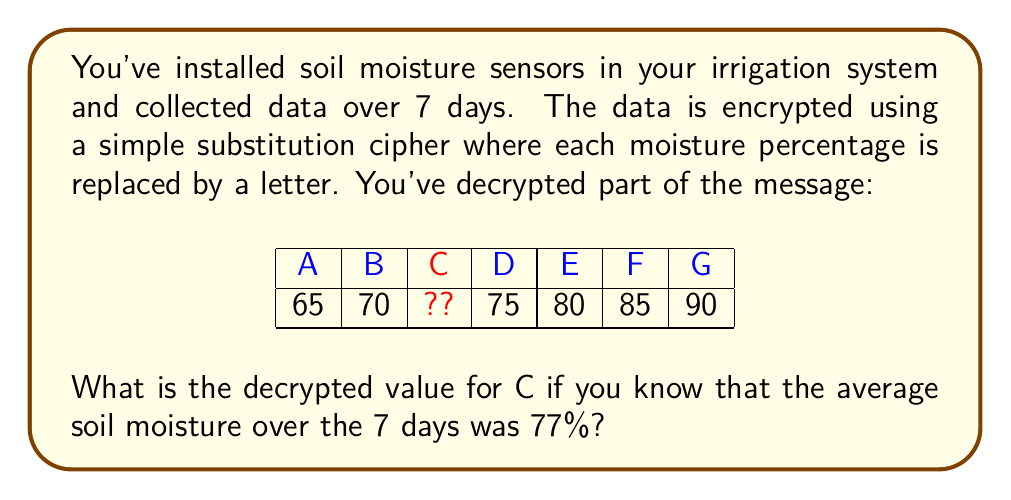Provide a solution to this math problem. Let's approach this step-by-step:

1) We have 7 data points, with 6 known values and 1 unknown (C).

2) We know the average is 77%. In mathematical terms:

   $$ \frac{A + B + C + D + E + F + G}{7} = 77 $$

3) Substituting the known values:

   $$ \frac{65 + 70 + C + 75 + 80 + 85 + 90}{7} = 77 $$

4) Multiply both sides by 7:

   $$ 65 + 70 + C + 75 + 80 + 85 + 90 = 77 * 7 = 539 $$

5) Sum the known values:

   $$ 65 + 70 + 75 + 80 + 85 + 90 = 465 $$

6) Subtract this sum from both sides:

   $$ C = 539 - 465 = 74 $$

Therefore, the decrypted value for C is 74%.
Answer: 74% 